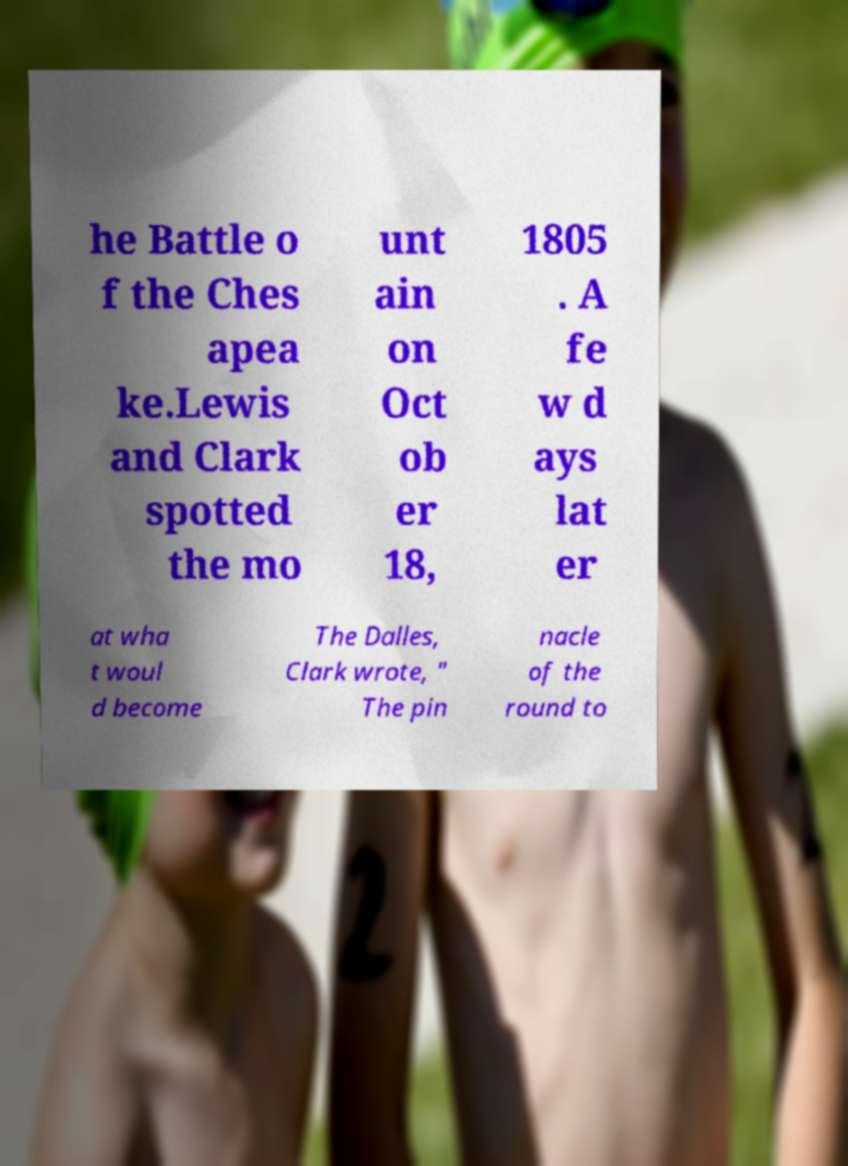There's text embedded in this image that I need extracted. Can you transcribe it verbatim? he Battle o f the Ches apea ke.Lewis and Clark spotted the mo unt ain on Oct ob er 18, 1805 . A fe w d ays lat er at wha t woul d become The Dalles, Clark wrote, " The pin nacle of the round to 